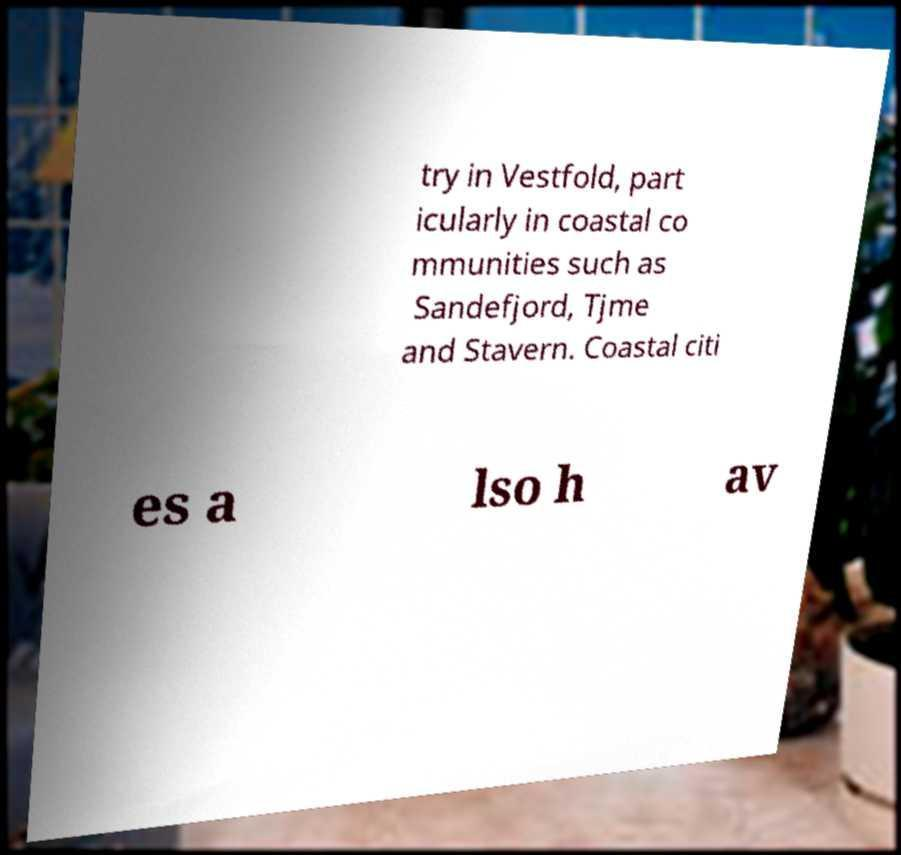Can you read and provide the text displayed in the image?This photo seems to have some interesting text. Can you extract and type it out for me? try in Vestfold, part icularly in coastal co mmunities such as Sandefjord, Tjme and Stavern. Coastal citi es a lso h av 